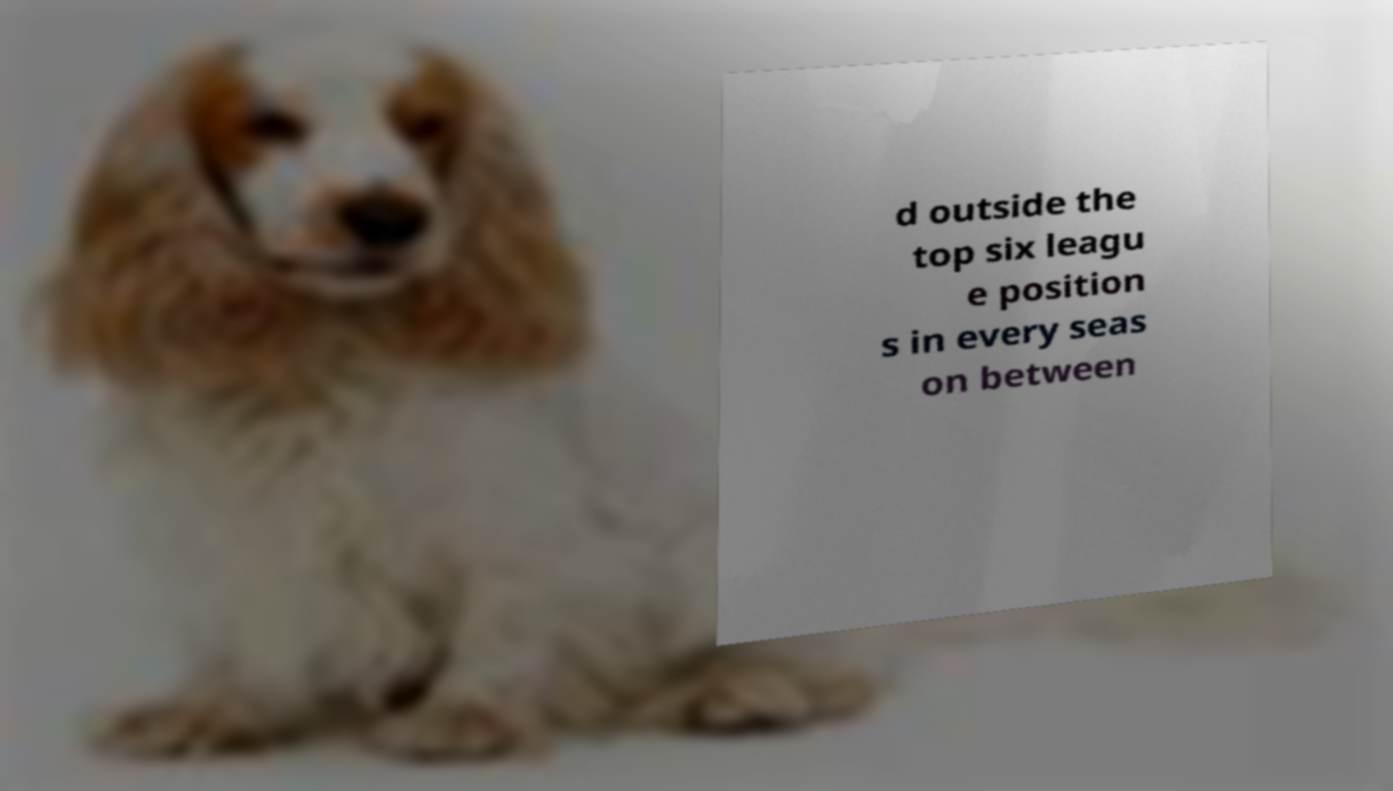There's text embedded in this image that I need extracted. Can you transcribe it verbatim? d outside the top six leagu e position s in every seas on between 